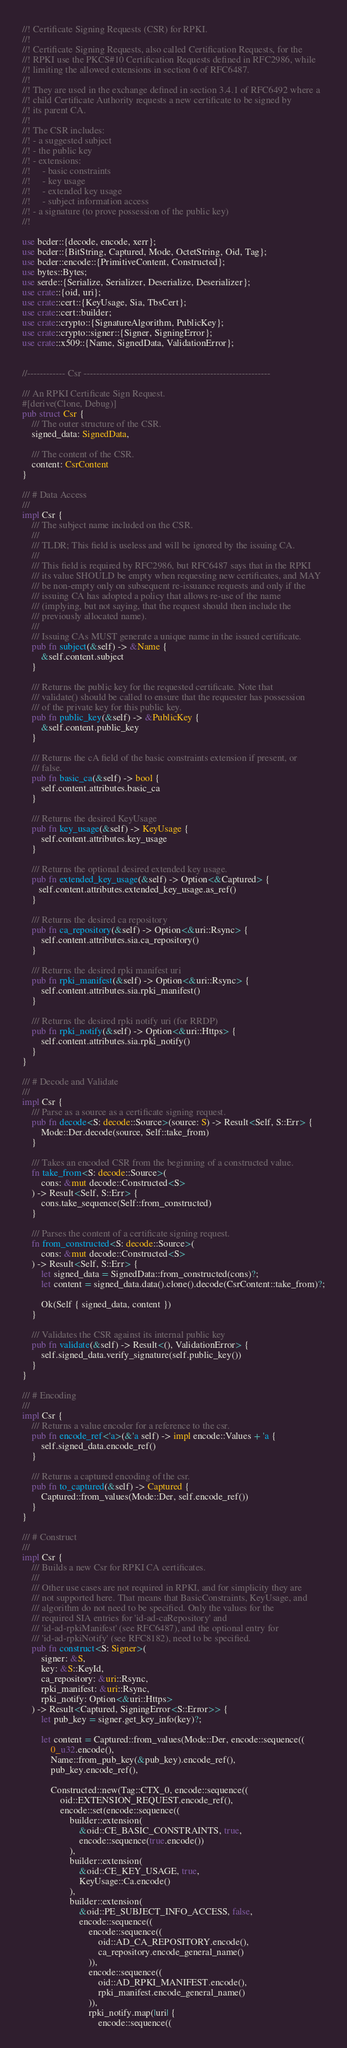<code> <loc_0><loc_0><loc_500><loc_500><_Rust_>//! Certificate Signing Requests (CSR) for RPKI.
//!
//! Certificate Signing Requests, also called Certification Requests, for the
//! RPKI use the PKCS#10 Certification Requests defined in RFC2986, while
//! limiting the allowed extensions in section 6 of RFC6487.
//!
//! They are used in the exchange defined in section 3.4.1 of RFC6492 where a
//! child Certificate Authority requests a new certificate to be signed by
//! its parent CA.
//!
//! The CSR includes:
//! - a suggested subject
//! - the public key
//! - extensions:
//!     - basic constraints
//!     - key usage
//!     - extended key usage
//!     - subject information access
//! - a signature (to prove possession of the public key)
//!

use bcder::{decode, encode, xerr};
use bcder::{BitString, Captured, Mode, OctetString, Oid, Tag};
use bcder::encode::{PrimitiveContent, Constructed};
use bytes::Bytes;
use serde::{Serialize, Serializer, Deserialize, Deserializer};
use crate::{oid, uri};
use crate::cert::{KeyUsage, Sia, TbsCert};
use crate::cert::builder;
use crate::crypto::{SignatureAlgorithm, PublicKey};
use crate::crypto::signer::{Signer, SigningError};
use crate::x509::{Name, SignedData, ValidationError};


//------------ Csr -----------------------------------------------------------

/// An RPKI Certificate Sign Request.
#[derive(Clone, Debug)]
pub struct Csr {
    /// The outer structure of the CSR.
    signed_data: SignedData,

    /// The content of the CSR.
    content: CsrContent
}

/// # Data Access
///
impl Csr {
    /// The subject name included on the CSR.
    ///
    /// TLDR; This field is useless and will be ignored by the issuing CA.
    ///
    /// This field is required by RFC2986, but RFC6487 says that in the RPKI
    /// its value SHOULD be empty when requesting new certificates, and MAY
    /// be non-empty only on subsequent re-issuance requests and only if the
    /// issuing CA has adopted a policy that allows re-use of the name
    /// (implying, but not saying, that the request should then include the
    /// previously allocated name).
    ///
    /// Issuing CAs MUST generate a unique name in the issued certificate.
    pub fn subject(&self) -> &Name {
        &self.content.subject
    }

    /// Returns the public key for the requested certificate. Note that
    /// validate() should be called to ensure that the requester has possession
    /// of the private key for this public key.
    pub fn public_key(&self) -> &PublicKey {
        &self.content.public_key
    }

    /// Returns the cA field of the basic constraints extension if present, or
    /// false.
    pub fn basic_ca(&self) -> bool {
        self.content.attributes.basic_ca
    }

    /// Returns the desired KeyUsage
    pub fn key_usage(&self) -> KeyUsage {
        self.content.attributes.key_usage
    }

    /// Returns the optional desired extended key usage.
    pub fn extended_key_usage(&self) -> Option<&Captured> {
       self.content.attributes.extended_key_usage.as_ref()
    }

    /// Returns the desired ca repository
    pub fn ca_repository(&self) -> Option<&uri::Rsync> {
        self.content.attributes.sia.ca_repository()
    }

    /// Returns the desired rpki manifest uri
    pub fn rpki_manifest(&self) -> Option<&uri::Rsync> {
        self.content.attributes.sia.rpki_manifest()
    }

    /// Returns the desired rpki notify uri (for RRDP)
    pub fn rpki_notify(&self) -> Option<&uri::Https> {
        self.content.attributes.sia.rpki_notify()
    }
}

/// # Decode and Validate
///
impl Csr {
    /// Parse as a source as a certificate signing request.
    pub fn decode<S: decode::Source>(source: S) -> Result<Self, S::Err> {
        Mode::Der.decode(source, Self::take_from)
    }

    /// Takes an encoded CSR from the beginning of a constructed value.
    fn take_from<S: decode::Source>(
        cons: &mut decode::Constructed<S>
    ) -> Result<Self, S::Err> {
        cons.take_sequence(Self::from_constructed)
    }

    /// Parses the content of a certificate signing request.
    fn from_constructed<S: decode::Source>(
        cons: &mut decode::Constructed<S>
    ) -> Result<Self, S::Err> {
        let signed_data = SignedData::from_constructed(cons)?;
        let content = signed_data.data().clone().decode(CsrContent::take_from)?;

        Ok(Self { signed_data, content })
    }

    /// Validates the CSR against its internal public key
    pub fn validate(&self) -> Result<(), ValidationError> {
        self.signed_data.verify_signature(self.public_key())
    }
}

/// # Encoding
///
impl Csr {
    /// Returns a value encoder for a reference to the csr.
    pub fn encode_ref<'a>(&'a self) -> impl encode::Values + 'a {
        self.signed_data.encode_ref()
    }

    /// Returns a captured encoding of the csr.
    pub fn to_captured(&self) -> Captured {
        Captured::from_values(Mode::Der, self.encode_ref())
    }
}

/// # Construct
///
impl Csr {
    /// Builds a new Csr for RPKI CA certificates.
    ///
    /// Other use cases are not required in RPKI, and for simplicity they are
    /// not supported here. That means that BasicConstraints, KeyUsage, and
    /// algorithm do not need to be specified. Only the values for the
    /// required SIA entries for 'id-ad-caRepository' and
    /// 'id-ad-rpkiManifest' (see RFC6487), and the optional entry for
    /// 'id-ad-rpkiNotify' (see RFC8182), need to be specified.
    pub fn construct<S: Signer>(
        signer: &S,
        key: &S::KeyId,
        ca_repository: &uri::Rsync,
        rpki_manifest: &uri::Rsync,
        rpki_notify: Option<&uri::Https>
    ) -> Result<Captured, SigningError<S::Error>> {
        let pub_key = signer.get_key_info(key)?;

        let content = Captured::from_values(Mode::Der, encode::sequence((
            0_u32.encode(),
            Name::from_pub_key(&pub_key).encode_ref(),
            pub_key.encode_ref(),

            Constructed::new(Tag::CTX_0, encode::sequence((
                oid::EXTENSION_REQUEST.encode_ref(),
                encode::set(encode::sequence((
                    builder::extension(
                        &oid::CE_BASIC_CONSTRAINTS, true,
                        encode::sequence(true.encode())
                    ),
                    builder::extension(
                        &oid::CE_KEY_USAGE, true,
                        KeyUsage::Ca.encode()
                    ),
                    builder::extension(
                        &oid::PE_SUBJECT_INFO_ACCESS, false,
                        encode::sequence((
                            encode::sequence((
                                oid::AD_CA_REPOSITORY.encode(),
                                ca_repository.encode_general_name()
                            )),
                            encode::sequence((
                                oid::AD_RPKI_MANIFEST.encode(),
                                rpki_manifest.encode_general_name()
                            )),
                            rpki_notify.map(|uri| {
                                encode::sequence((</code> 